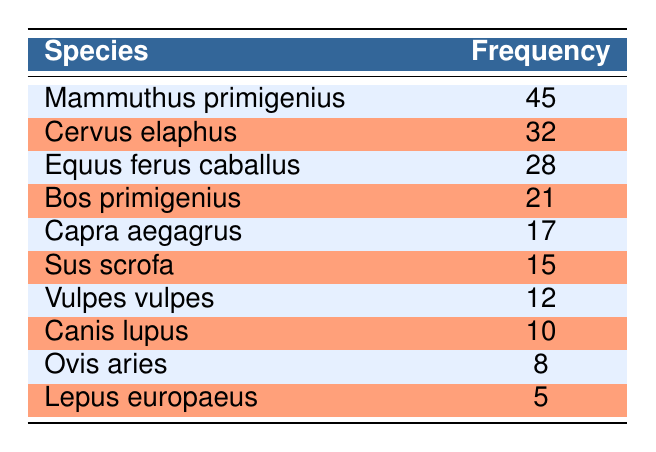What is the species with the highest frequency identified from the faunal remains? The table lists species along with their frequencies. By observing the frequencies, it is clear that "Mammuthus primigenius" has the highest frequency at 45.
Answer: Mammuthus primigenius How many species have a frequency greater than 20? To determine this, we can count the species listed in the table with a frequency of greater than 20. These species are "Mammuthus primigenius" (45), "Cervus elaphus" (32), "Equus ferus caballus" (28), and "Bos primigenius" (21), totaling 4 species.
Answer: 4 What is the frequency difference between "Cervus elaphus" and "Sus scrofa"? We find the frequency of "Cervus elaphus", which is 32, and "Sus scrofa", which is 15. The difference is calculated by subtracting the lower frequency from the higher frequency: 32 - 15 = 17.
Answer: 17 Is "Capra aegagrus" more frequent than "Ovis aries"? From the table, "Capra aegagrus" has a frequency of 17 and "Ovis aries" has a frequency of 8. Since 17 is greater than 8, the statement is true.
Answer: Yes What is the total frequency of all species listed in the table? We need to sum the frequencies of all species in the table: (45 + 32 + 28 + 21 + 17 + 15 + 12 + 10 + 8 + 5) = 293. Therefore, the total frequency is 293.
Answer: 293 Which species has the second highest frequency, and what is its frequency? By examining the frequencies in descending order, we find "Cervus elaphus" at 32 following "Mammuthus primigenius" at 45, making "Cervus elaphus" the second highest frequency species.
Answer: Cervus elaphus, 32 How many species have a frequency less than 10? We can check each species for frequencies below 10. "Canis lupus" (10), "Ovis aries" (8), and "Lepus europaeus" (5) are the only species; thus only "Ovis aries" and "Lepus europaeus" fit that criteria, totaling 2 species.
Answer: 2 What is the average frequency of the species listed in the table? The average is calculated by dividing the total frequency (293) by the number of species (10). Thus, 293 / 10 = 29.3. The average frequency is 29.3.
Answer: 29.3 